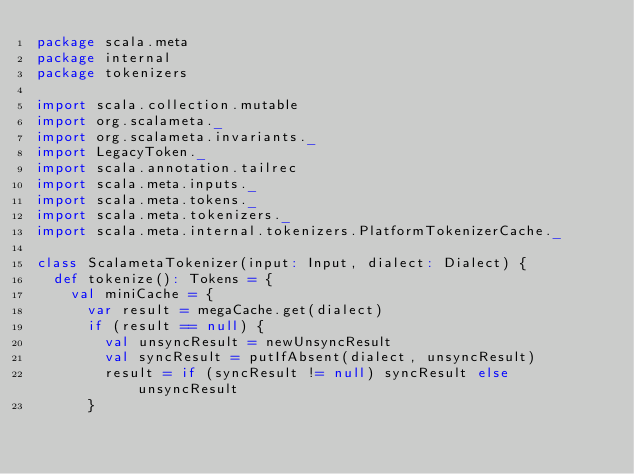<code> <loc_0><loc_0><loc_500><loc_500><_Scala_>package scala.meta
package internal
package tokenizers

import scala.collection.mutable
import org.scalameta._
import org.scalameta.invariants._
import LegacyToken._
import scala.annotation.tailrec
import scala.meta.inputs._
import scala.meta.tokens._
import scala.meta.tokenizers._
import scala.meta.internal.tokenizers.PlatformTokenizerCache._

class ScalametaTokenizer(input: Input, dialect: Dialect) {
  def tokenize(): Tokens = {
    val miniCache = {
      var result = megaCache.get(dialect)
      if (result == null) {
        val unsyncResult = newUnsyncResult
        val syncResult = putIfAbsent(dialect, unsyncResult)
        result = if (syncResult != null) syncResult else unsyncResult
      }</code> 